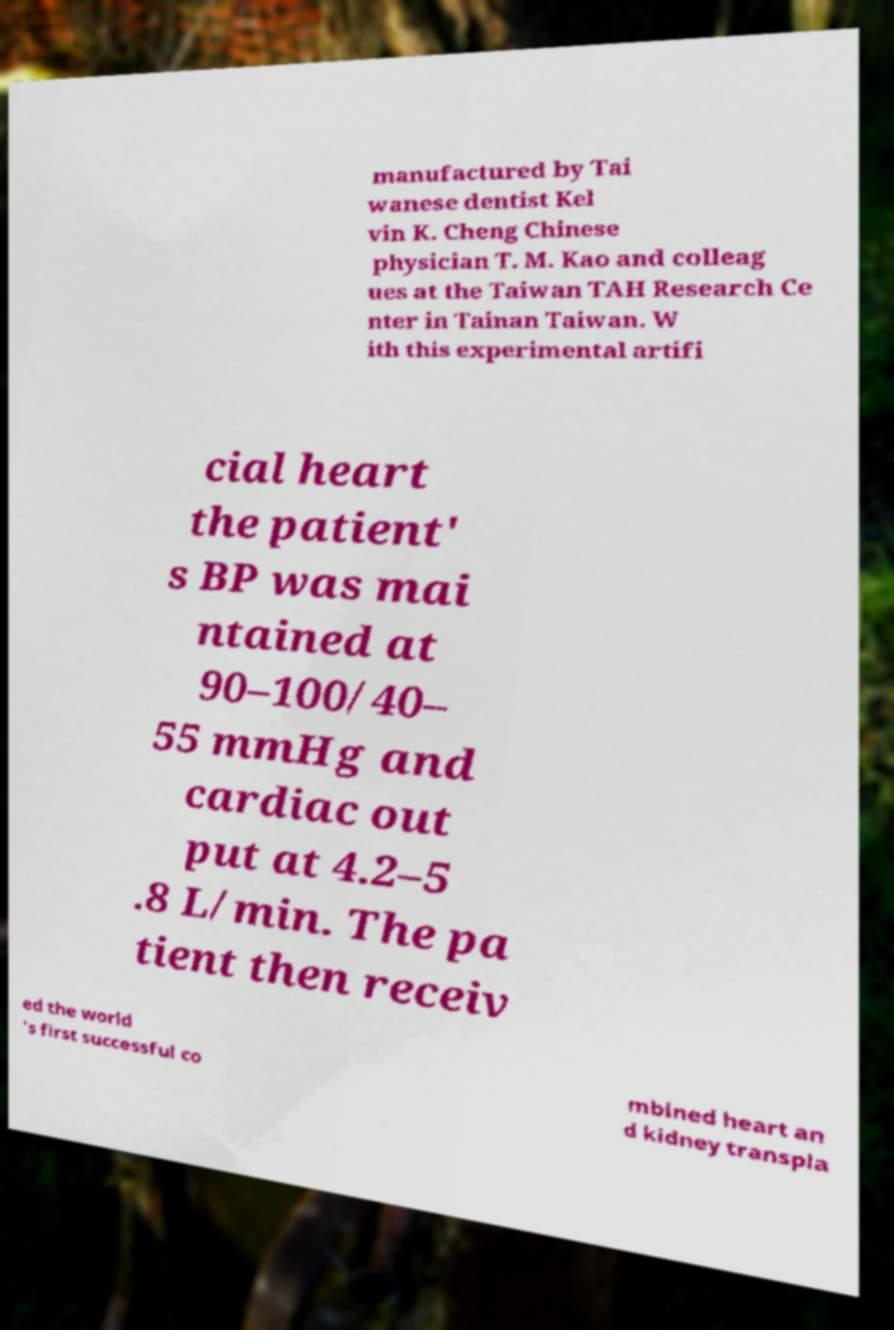Could you assist in decoding the text presented in this image and type it out clearly? manufactured by Tai wanese dentist Kel vin K. Cheng Chinese physician T. M. Kao and colleag ues at the Taiwan TAH Research Ce nter in Tainan Taiwan. W ith this experimental artifi cial heart the patient' s BP was mai ntained at 90–100/40– 55 mmHg and cardiac out put at 4.2–5 .8 L/min. The pa tient then receiv ed the world 's first successful co mbined heart an d kidney transpla 